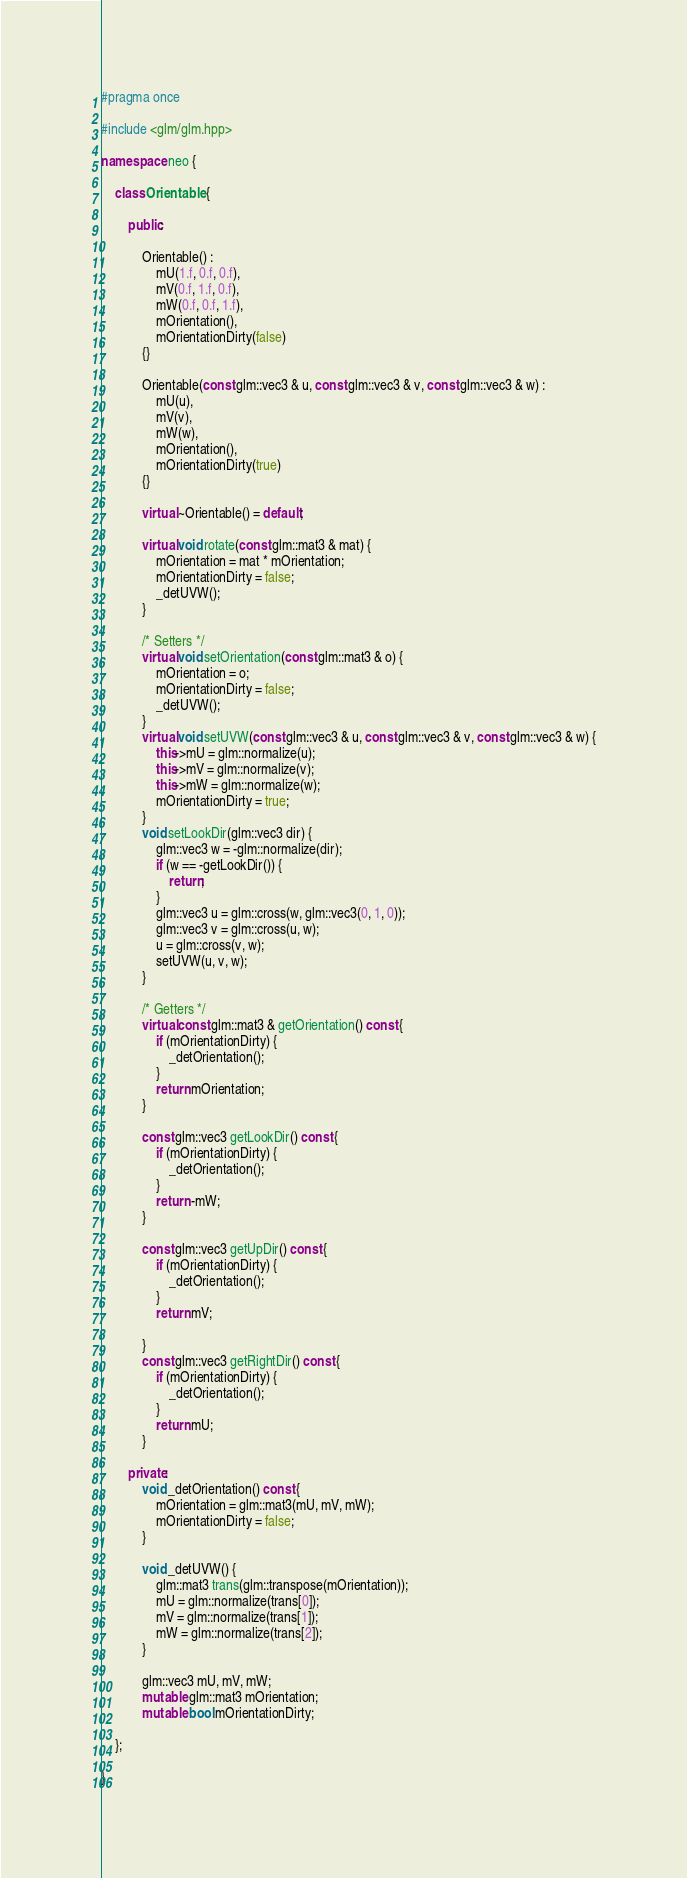<code> <loc_0><loc_0><loc_500><loc_500><_C++_>#pragma once

#include <glm/glm.hpp>

namespace neo {

    class Orientable {

        public:

            Orientable() :
                mU(1.f, 0.f, 0.f),
                mV(0.f, 1.f, 0.f),
                mW(0.f, 0.f, 1.f),
                mOrientation(),
                mOrientationDirty(false)
            {}

            Orientable(const glm::vec3 & u, const glm::vec3 & v, const glm::vec3 & w) :
                mU(u),
                mV(v),
                mW(w),
                mOrientation(),
                mOrientationDirty(true)
            {}

            virtual ~Orientable() = default;

            virtual void rotate(const glm::mat3 & mat) {
                mOrientation = mat * mOrientation;
                mOrientationDirty = false;
                _detUVW();
            }
            
            /* Setters */
            virtual void setOrientation(const glm::mat3 & o) {
                mOrientation = o;
                mOrientationDirty = false;
                _detUVW();
            }
            virtual void setUVW(const glm::vec3 & u, const glm::vec3 & v, const glm::vec3 & w) {
                this->mU = glm::normalize(u);
                this->mV = glm::normalize(v);
                this->mW = glm::normalize(w);
                mOrientationDirty = true;
            }
            void setLookDir(glm::vec3 dir) {
                glm::vec3 w = -glm::normalize(dir);
                if (w == -getLookDir()) {
                    return;
                }
                glm::vec3 u = glm::cross(w, glm::vec3(0, 1, 0));
                glm::vec3 v = glm::cross(u, w);
                u = glm::cross(v, w);
                setUVW(u, v, w);
            }

            /* Getters */
            virtual const glm::mat3 & getOrientation() const {
                if (mOrientationDirty) {
                    _detOrientation();
                }
                return mOrientation;
            }

            const glm::vec3 getLookDir() const {
                if (mOrientationDirty) {
                    _detOrientation();
                }
                return -mW;
            }

            const glm::vec3 getUpDir() const {
                if (mOrientationDirty) {
                    _detOrientation();
                }
                return mV;
 
            }
            const glm::vec3 getRightDir() const {
                if (mOrientationDirty) {
                    _detOrientation();
                }
                return mU;
            }

        private:    
            void _detOrientation() const {
                mOrientation = glm::mat3(mU, mV, mW);
                mOrientationDirty = false;
            }

            void _detUVW() {
                glm::mat3 trans(glm::transpose(mOrientation));
                mU = glm::normalize(trans[0]);
                mV = glm::normalize(trans[1]);
                mW = glm::normalize(trans[2]);
            }

            glm::vec3 mU, mV, mW;
            mutable glm::mat3 mOrientation;
            mutable bool mOrientationDirty;

    };

}</code> 